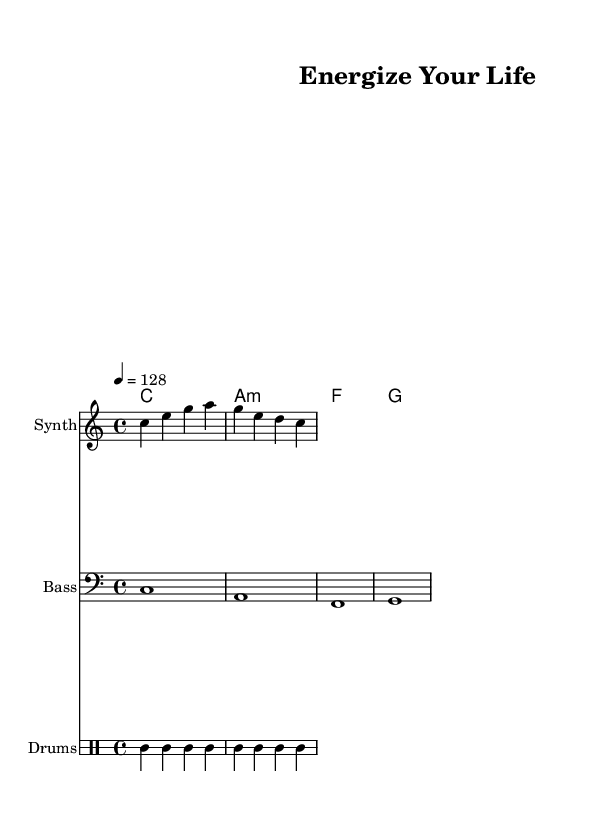What is the key signature of this music? The key signature is indicated by the absence of sharps or flats on the staff, which corresponds to C major.
Answer: C major What is the time signature of the piece? The time signature is found at the beginning of the staff and indicates how many beats are in a measure, which is 4 beats per measure.
Answer: 4/4 What is the tempo marking for this piece? The tempo marking is indicated by the number above the staff, which shows the speed of the music, set to 128 beats per minute.
Answer: 128 Which instrument is designated as the melody? The instrument for the melody is labeled as "Synth" in the score, indicating that this staff represents the synth melody part.
Answer: Synth How many measures are in the melody section? By counting the measures within the melody staff, each measure-separated by bars indicates there are 2 measures in the melody.
Answer: 2 What is the lyrical theme of this piece? The lyrics provided suggest a theme of physical activity and vitality, encouraging movement and a sense of liveliness.
Answer: Wellness Which chord is used in the first measure? The chord in the first measure can be identified from the chord notation, which is C major, represented by the notes C, E, and G.
Answer: C major 